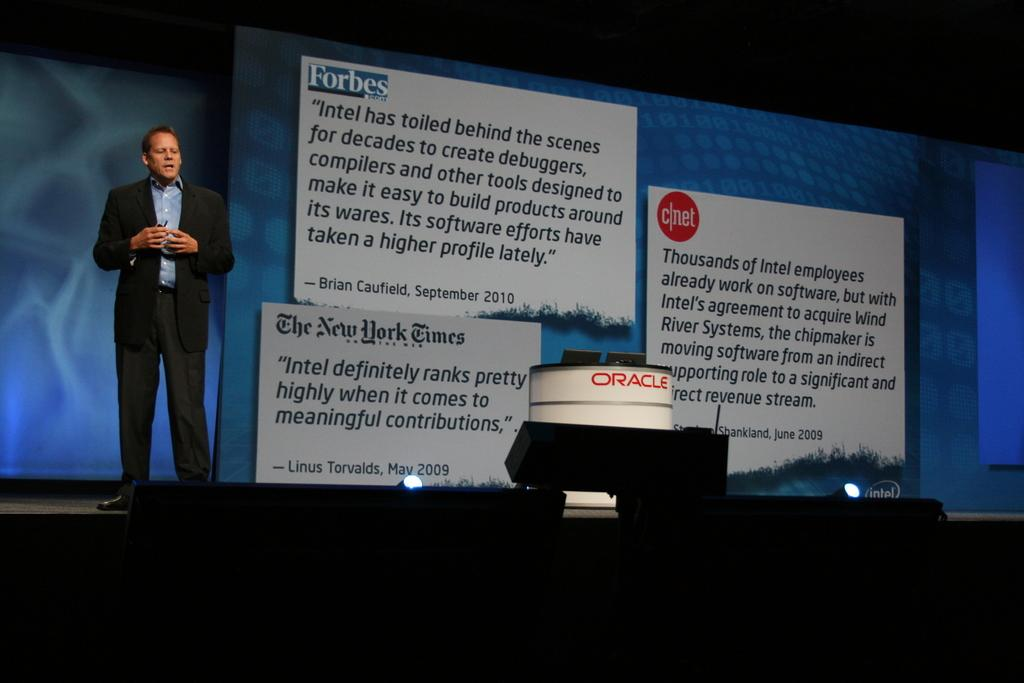What is the position of the person in the image? The person is standing on the left side in the image. What is the person wearing? The person is wearing a suit. What can be seen at the back of the image? There is a display screen at the back. Where are the lights located in the image? The lights are at the bottom of the image. Is there a match being played in the image? There is no indication of a match or any sports activity in the image. Is the person wearing a mask in the image? The person is not wearing a mask in the image; they are wearing a suit. 